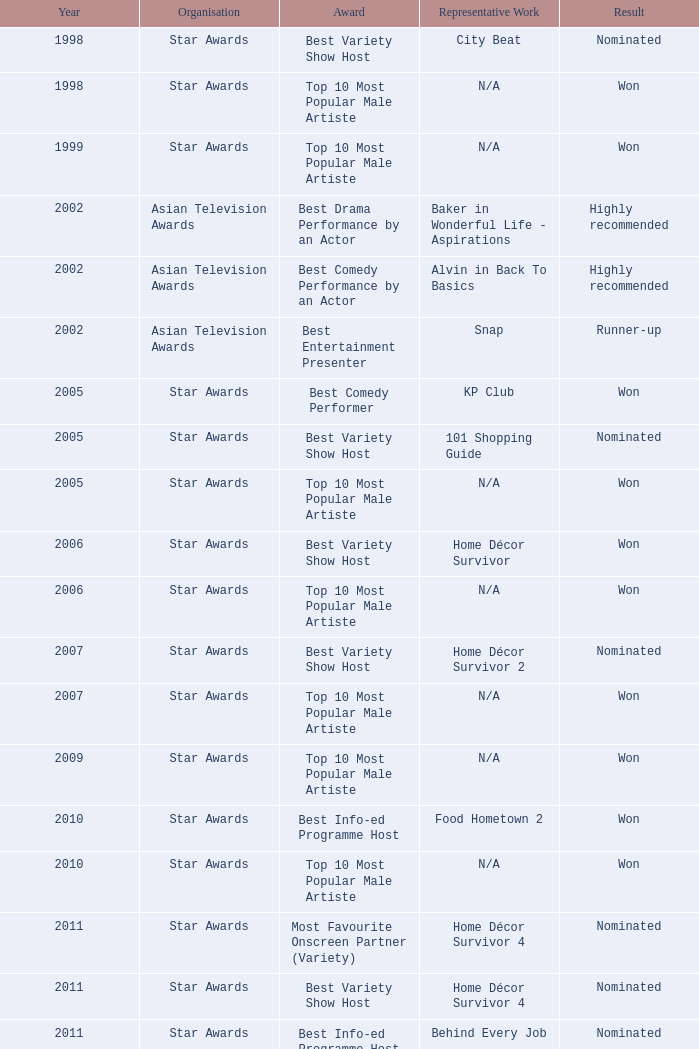Which organization received a nomination for the best info-ed program host award in 2011? Star Awards. 